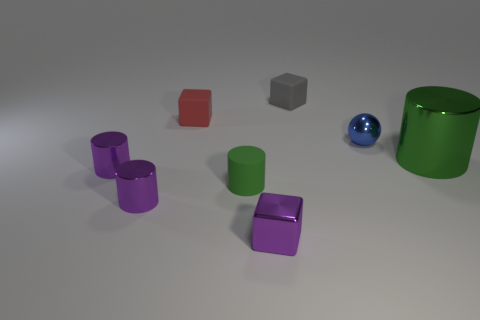Add 1 big cylinders. How many objects exist? 9 Subtract all balls. How many objects are left? 7 Subtract all rubber blocks. Subtract all large purple rubber things. How many objects are left? 6 Add 5 rubber objects. How many rubber objects are left? 8 Add 8 green matte things. How many green matte things exist? 9 Subtract 1 purple blocks. How many objects are left? 7 